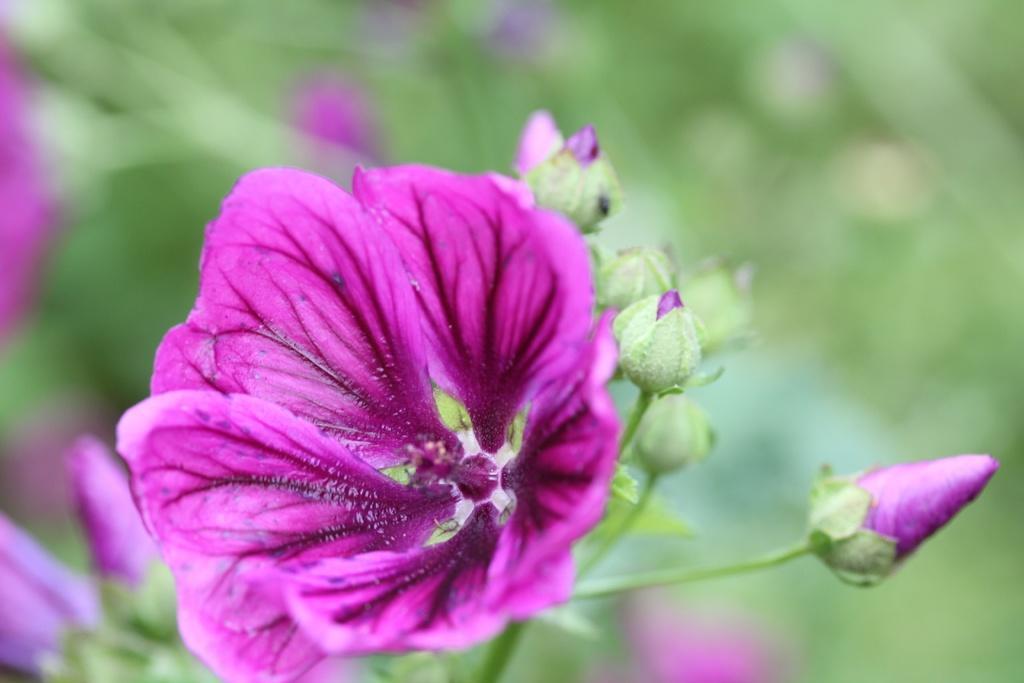In one or two sentences, can you explain what this image depicts? In the center of the image we can see flowers,which are in pink color. 